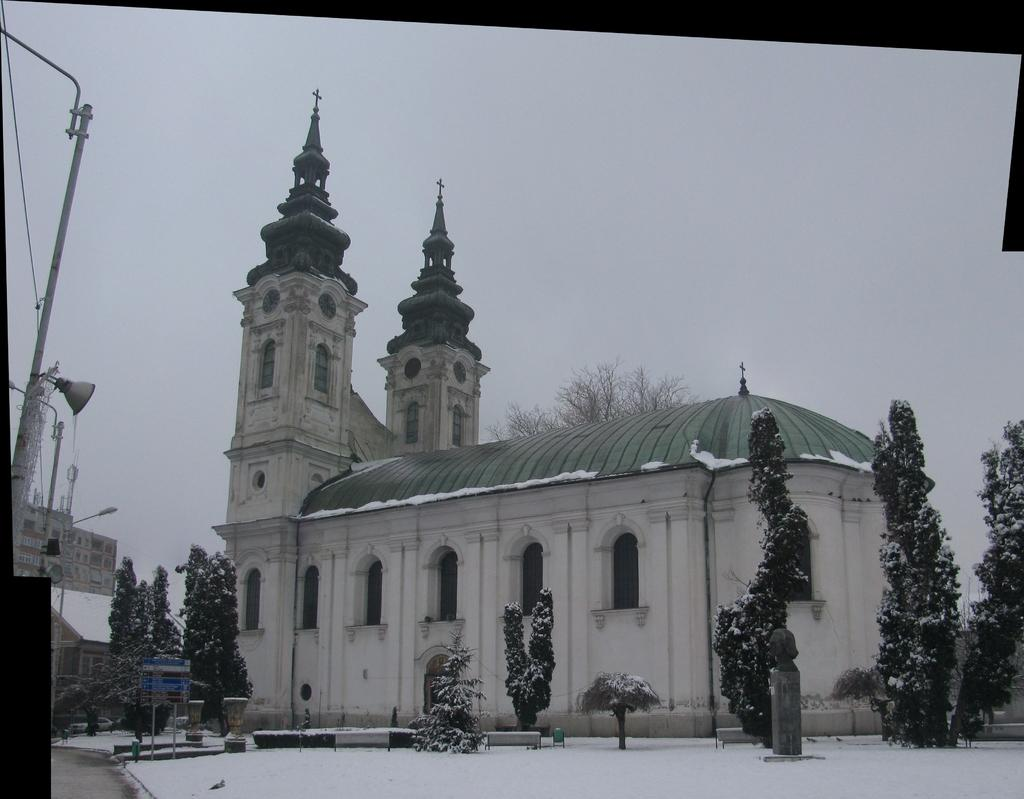What type of structures can be seen in the image? There are buildings in the image. What is the weather like in the image? The trees with snow suggest that it is snowing or has recently snowed in the image. What object can be used for displaying information or announcements? There is a board in the image. What device might be used for amplifying sound? There is a speaker in the image. What type of lighting is present in the image? There is a street light in the image. What is the tall, thin object in the image? There is a pole in the image. What can be seen above the ground in the image? The sky is visible in the image. Where is the cushion placed in the image? There is no cushion present in the image. What type of oil can be seen dripping from the speaker in the image? There is no oil present in the image, and the speaker is not depicted as dripping anything. 